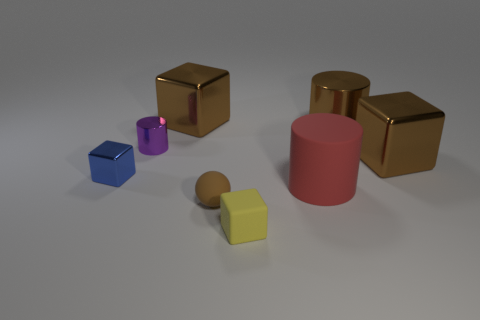Add 1 tiny gray spheres. How many objects exist? 9 Subtract all balls. How many objects are left? 7 Add 2 purple metallic cylinders. How many purple metallic cylinders are left? 3 Add 8 gray matte objects. How many gray matte objects exist? 8 Subtract 0 gray spheres. How many objects are left? 8 Subtract all things. Subtract all small gray rubber cylinders. How many objects are left? 0 